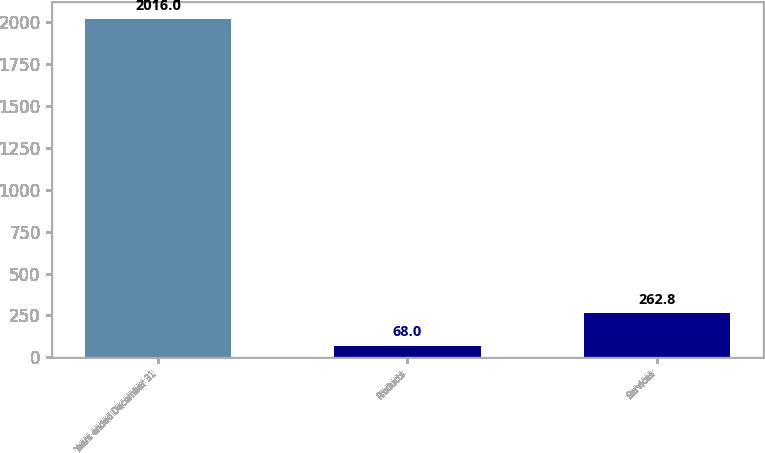Convert chart. <chart><loc_0><loc_0><loc_500><loc_500><bar_chart><fcel>Years ended December 31<fcel>Products<fcel>Services<nl><fcel>2016<fcel>68<fcel>262.8<nl></chart> 